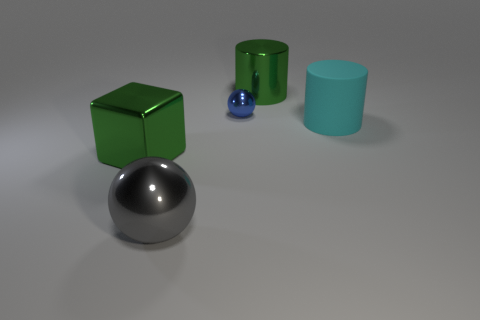Add 3 shiny cubes. How many objects exist? 8 Subtract all cylinders. How many objects are left? 3 Add 5 cyan objects. How many cyan objects are left? 6 Add 5 blue metal spheres. How many blue metal spheres exist? 6 Subtract 0 gray cubes. How many objects are left? 5 Subtract all gray shiny objects. Subtract all gray metallic things. How many objects are left? 3 